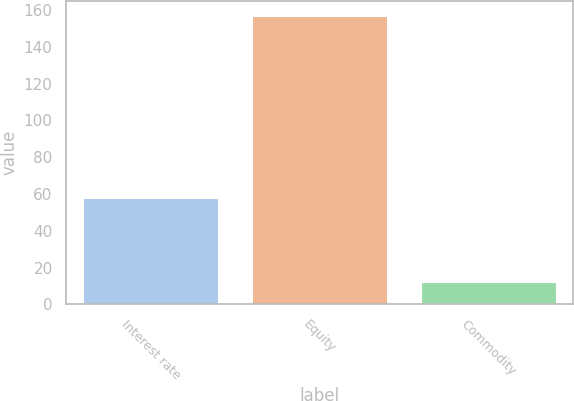Convert chart. <chart><loc_0><loc_0><loc_500><loc_500><bar_chart><fcel>Interest rate<fcel>Equity<fcel>Commodity<nl><fcel>58<fcel>157<fcel>12<nl></chart> 